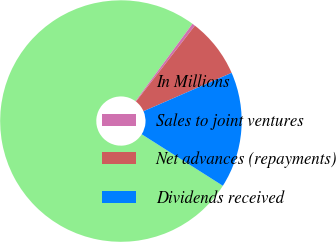Convert chart. <chart><loc_0><loc_0><loc_500><loc_500><pie_chart><fcel>In Millions<fcel>Sales to joint ventures<fcel>Net advances (repayments)<fcel>Dividends received<nl><fcel>76.1%<fcel>0.4%<fcel>7.97%<fcel>15.54%<nl></chart> 